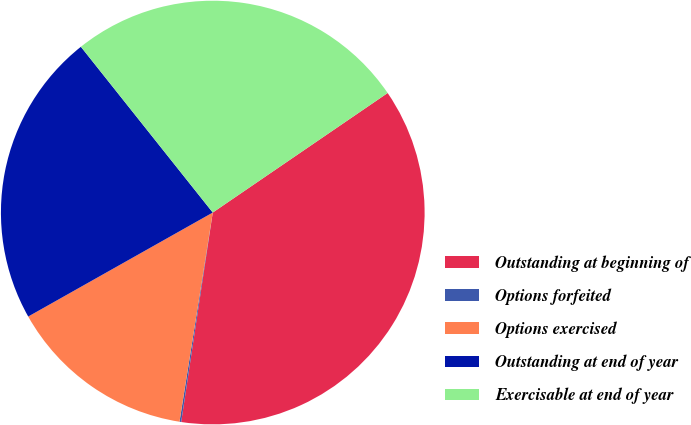Convert chart to OTSL. <chart><loc_0><loc_0><loc_500><loc_500><pie_chart><fcel>Outstanding at beginning of<fcel>Options forfeited<fcel>Options exercised<fcel>Outstanding at end of year<fcel>Exercisable at end of year<nl><fcel>36.92%<fcel>0.13%<fcel>14.32%<fcel>22.47%<fcel>26.15%<nl></chart> 